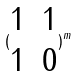Convert formula to latex. <formula><loc_0><loc_0><loc_500><loc_500>( \begin{matrix} 1 & 1 \\ 1 & 0 \end{matrix} ) ^ { m }</formula> 